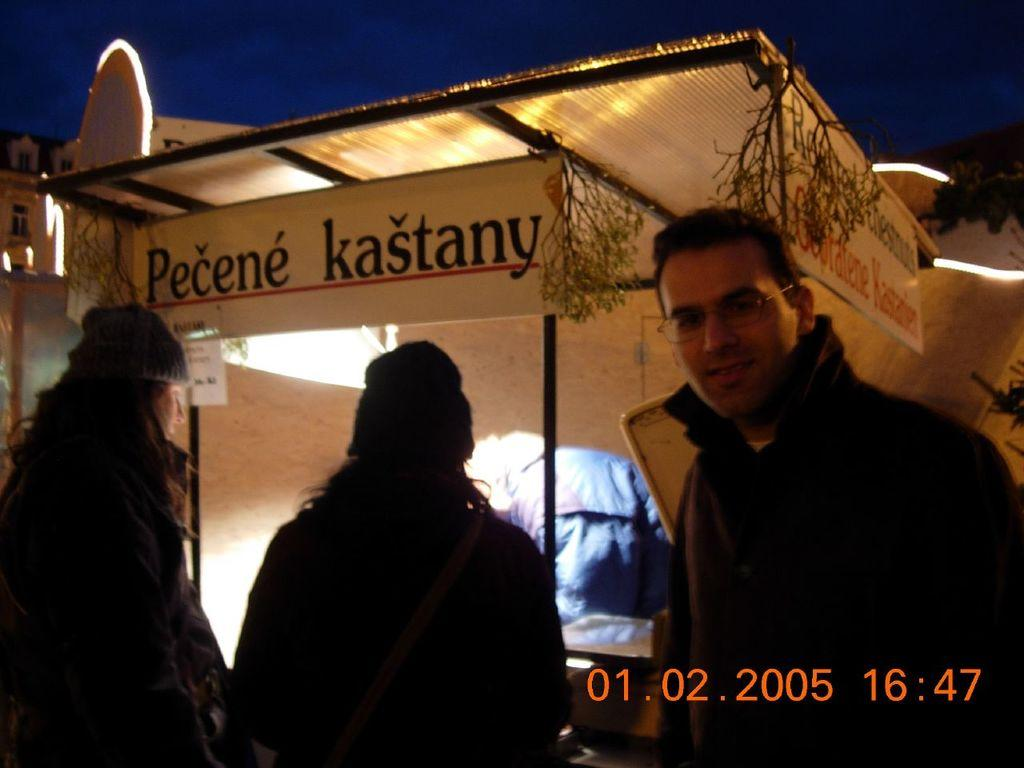How many people are in the image? There are three persons in the image. What can be seen in the background of the image? There is a shed in the background of the image. What objects are present in the image that have names on them? There are name boards in the image. What type of vegetation is present in the image? Small plants are present in the image. What is visible at the top of the image? The sky is visible at the top of the image. How does the sneeze of the person on the left affect the plants in the image? There is no person sneezing in the image, and therefore no such effect can be observed on the plants. 